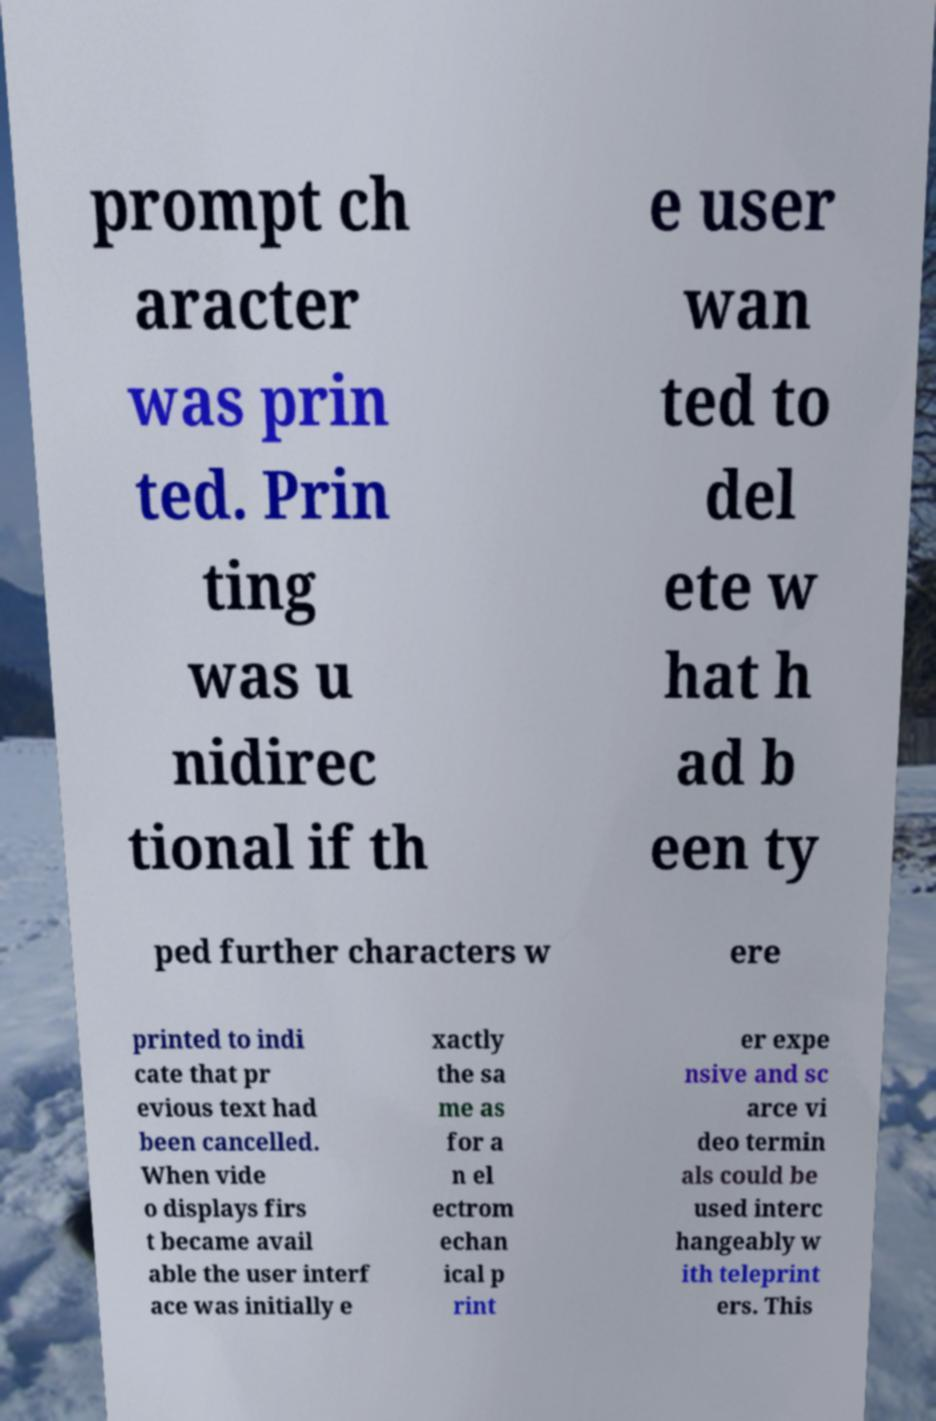I need the written content from this picture converted into text. Can you do that? prompt ch aracter was prin ted. Prin ting was u nidirec tional if th e user wan ted to del ete w hat h ad b een ty ped further characters w ere printed to indi cate that pr evious text had been cancelled. When vide o displays firs t became avail able the user interf ace was initially e xactly the sa me as for a n el ectrom echan ical p rint er expe nsive and sc arce vi deo termin als could be used interc hangeably w ith teleprint ers. This 